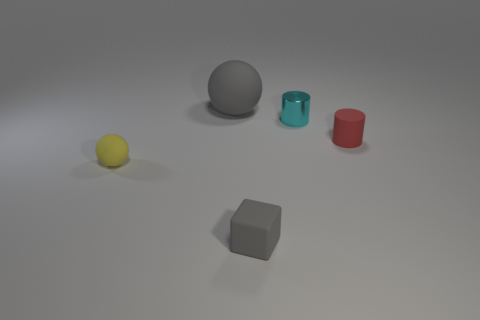Is the number of red matte objects less than the number of large purple matte things?
Offer a terse response. No. What shape is the gray thing in front of the gray rubber thing that is behind the tiny rubber block?
Your response must be concise. Cube. Is there anything else that is the same size as the gray sphere?
Keep it short and to the point. No. What shape is the tiny rubber thing that is to the left of the gray thing that is in front of the ball that is in front of the large gray ball?
Your answer should be compact. Sphere. How many objects are either things behind the tiny matte block or matte things that are on the left side of the gray block?
Provide a short and direct response. 4. Does the rubber cube have the same size as the sphere behind the red rubber thing?
Ensure brevity in your answer.  No. Is the material of the sphere in front of the shiny thing the same as the tiny cylinder right of the tiny metallic cylinder?
Keep it short and to the point. Yes. Are there an equal number of shiny cylinders to the left of the tiny yellow rubber sphere and tiny red things in front of the tiny shiny cylinder?
Offer a terse response. No. How many tiny balls are the same color as the metal cylinder?
Provide a succinct answer. 0. There is a small cube that is the same color as the big matte thing; what material is it?
Give a very brief answer. Rubber. 